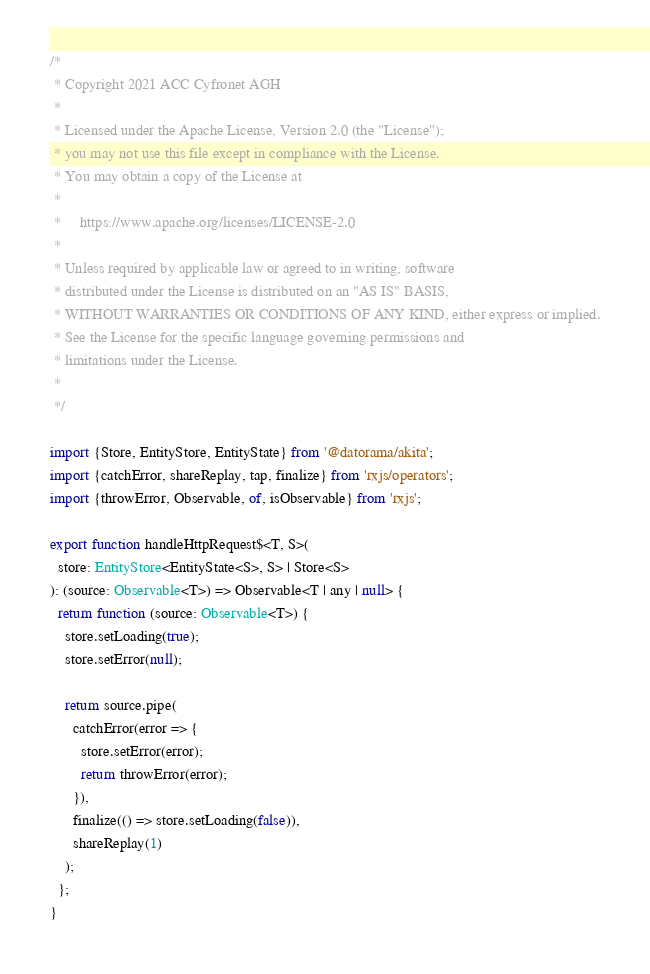Convert code to text. <code><loc_0><loc_0><loc_500><loc_500><_TypeScript_>/*
 * Copyright 2021 ACC Cyfronet AGH
 *
 * Licensed under the Apache License, Version 2.0 (the "License");
 * you may not use this file except in compliance with the License.
 * You may obtain a copy of the License at
 *
 *     https://www.apache.org/licenses/LICENSE-2.0
 *
 * Unless required by applicable law or agreed to in writing, software
 * distributed under the License is distributed on an "AS IS" BASIS,
 * WITHOUT WARRANTIES OR CONDITIONS OF ANY KIND, either express or implied.
 * See the License for the specific language governing permissions and
 * limitations under the License.
 *
 */

import {Store, EntityStore, EntityState} from '@datorama/akita';
import {catchError, shareReplay, tap, finalize} from 'rxjs/operators';
import {throwError, Observable, of, isObservable} from 'rxjs';

export function handleHttpRequest$<T, S>(
  store: EntityStore<EntityState<S>, S> | Store<S>
): (source: Observable<T>) => Observable<T | any | null> {
  return function (source: Observable<T>) {
    store.setLoading(true);
    store.setError(null);

    return source.pipe(
      catchError(error => {
        store.setError(error);
        return throwError(error);
      }),
      finalize(() => store.setLoading(false)),
      shareReplay(1)
    );
  };
}
</code> 